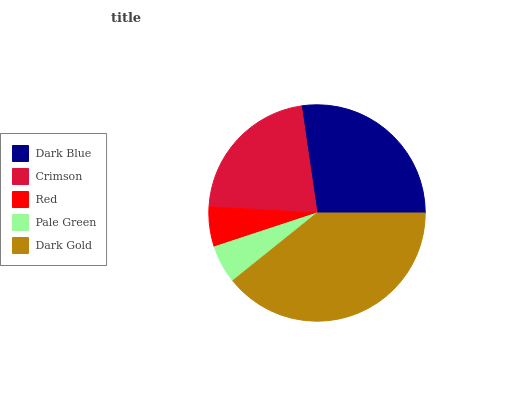Is Pale Green the minimum?
Answer yes or no. Yes. Is Dark Gold the maximum?
Answer yes or no. Yes. Is Crimson the minimum?
Answer yes or no. No. Is Crimson the maximum?
Answer yes or no. No. Is Dark Blue greater than Crimson?
Answer yes or no. Yes. Is Crimson less than Dark Blue?
Answer yes or no. Yes. Is Crimson greater than Dark Blue?
Answer yes or no. No. Is Dark Blue less than Crimson?
Answer yes or no. No. Is Crimson the high median?
Answer yes or no. Yes. Is Crimson the low median?
Answer yes or no. Yes. Is Dark Blue the high median?
Answer yes or no. No. Is Dark Blue the low median?
Answer yes or no. No. 